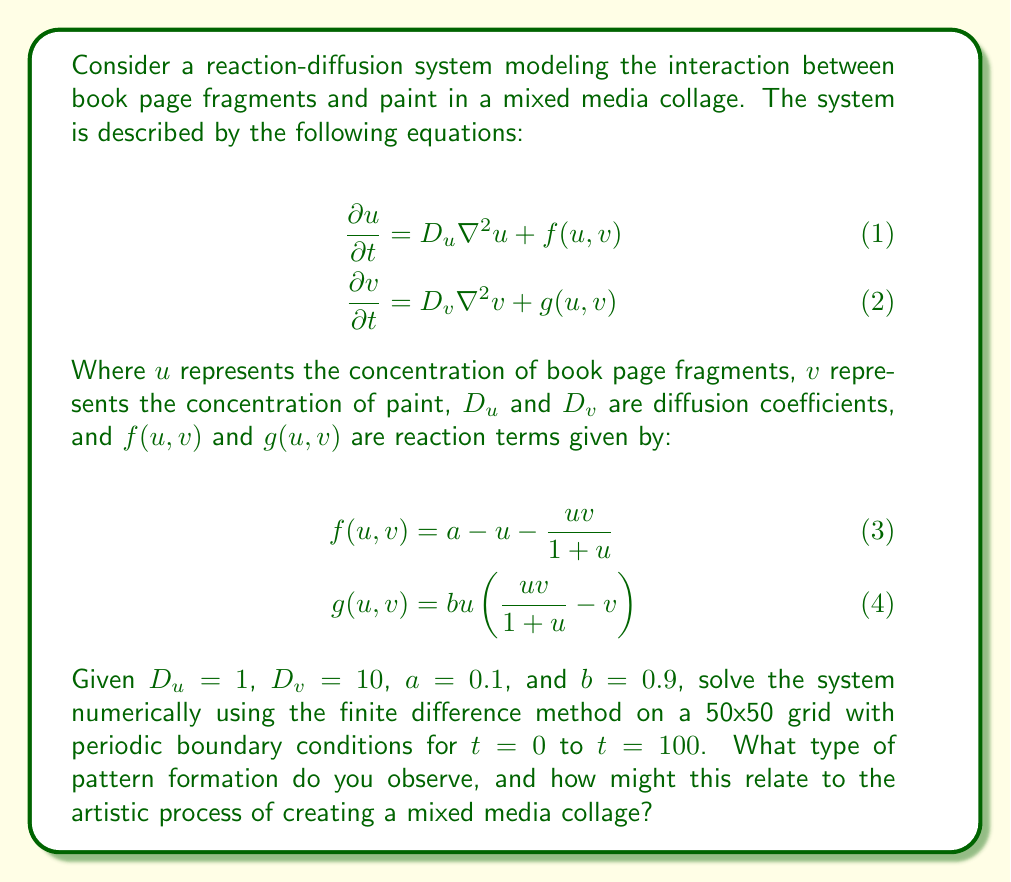Teach me how to tackle this problem. To solve this reaction-diffusion system numerically, we'll use the finite difference method with an explicit time-stepping scheme. Here's a step-by-step approach:

1. Discretize the spatial domain into a 50x50 grid with periodic boundary conditions.

2. Initialize $u$ and $v$ with small random perturbations around a homogeneous steady state.

3. For each time step:
   a. Calculate the Laplacian of $u$ and $v$ using the five-point stencil:
      $$\nabla^2 u_{i,j} \approx \frac{u_{i+1,j} + u_{i-1,j} + u_{i,j+1} + u_{i,j-1} - 4u_{i,j}}{(\Delta x)^2}$$
   b. Calculate the reaction terms $f(u,v)$ and $g(u,v)$.
   c. Update $u$ and $v$ using the forward Euler method:
      $$\begin{align}
      u_{i,j}^{n+1} &= u_{i,j}^n + \Delta t(D_u \nabla^2 u_{i,j}^n + f(u_{i,j}^n, v_{i,j}^n)) \\
      v_{i,j}^{n+1} &= v_{i,j}^n + \Delta t(D_v \nabla^2 v_{i,j}^n + g(u_{i,j}^n, v_{i,j}^n))
      \end{align}$$

4. Repeat step 3 for the desired number of time steps.

5. Analyze the resulting patterns.

When implementing this numerically, we observe the formation of spot patterns. These patterns emerge from the initial random perturbations and evolve over time due to the interplay between diffusion and reaction terms.

The observed spot patterns can be interpreted in the context of mixed media collage creation:

1. Book page fragments (u) tend to cluster together, forming "islands" or spots.
2. Paint (v) diffuses more quickly (higher $D_v$) and fills the spaces between the book page clusters.
3. The interaction between book fragments and paint creates areas of high contrast, similar to how a collage artist might juxtapose different materials.
4. The evolving nature of the patterns reflects the iterative process of creating a collage, where the artist continually adjusts and refines the composition.

This reaction-diffusion model captures the essence of how different materials in a mixed media collage might interact and create emergent patterns, providing inspiration for artistic composition and arrangement of elements.
Answer: The numerical solution of the reaction-diffusion system reveals the formation of spot patterns. These patterns relate to the mixed media collage creation process by simulating the clustering of book page fragments surrounded by diffusing paint, creating a dynamic interplay of materials that evolves over time. This mathematical model provides insights into how different elements in a collage might naturally organize and interact, potentially inspiring artistic decisions in composition and material placement. 